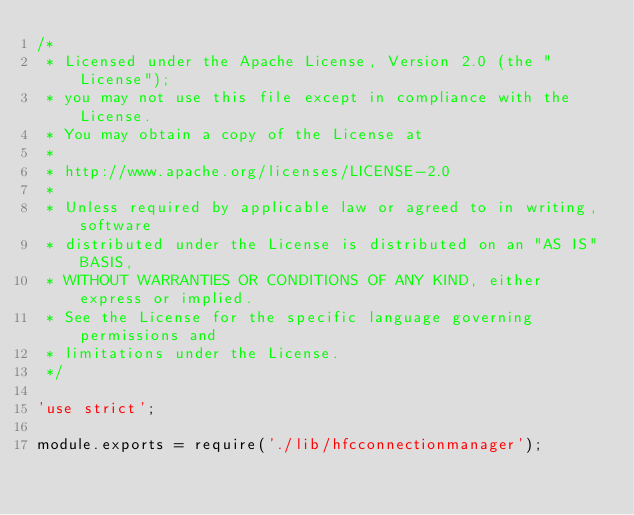Convert code to text. <code><loc_0><loc_0><loc_500><loc_500><_JavaScript_>/*
 * Licensed under the Apache License, Version 2.0 (the "License");
 * you may not use this file except in compliance with the License.
 * You may obtain a copy of the License at
 *
 * http://www.apache.org/licenses/LICENSE-2.0
 *
 * Unless required by applicable law or agreed to in writing, software
 * distributed under the License is distributed on an "AS IS" BASIS,
 * WITHOUT WARRANTIES OR CONDITIONS OF ANY KIND, either express or implied.
 * See the License for the specific language governing permissions and
 * limitations under the License.
 */

'use strict';

module.exports = require('./lib/hfcconnectionmanager');
</code> 